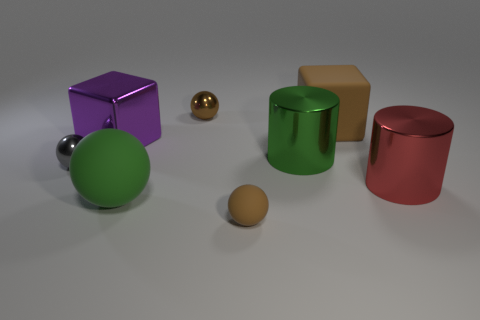Subtract all green balls. How many balls are left? 3 Subtract all red cylinders. How many cylinders are left? 1 Subtract all cylinders. How many objects are left? 6 Subtract 1 balls. How many balls are left? 3 Subtract all tiny metallic balls. Subtract all large brown matte cylinders. How many objects are left? 6 Add 4 large red metal cylinders. How many large red metal cylinders are left? 5 Add 1 tiny metallic objects. How many tiny metallic objects exist? 3 Add 1 yellow cylinders. How many objects exist? 9 Subtract 1 gray spheres. How many objects are left? 7 Subtract all gray cubes. Subtract all purple balls. How many cubes are left? 2 